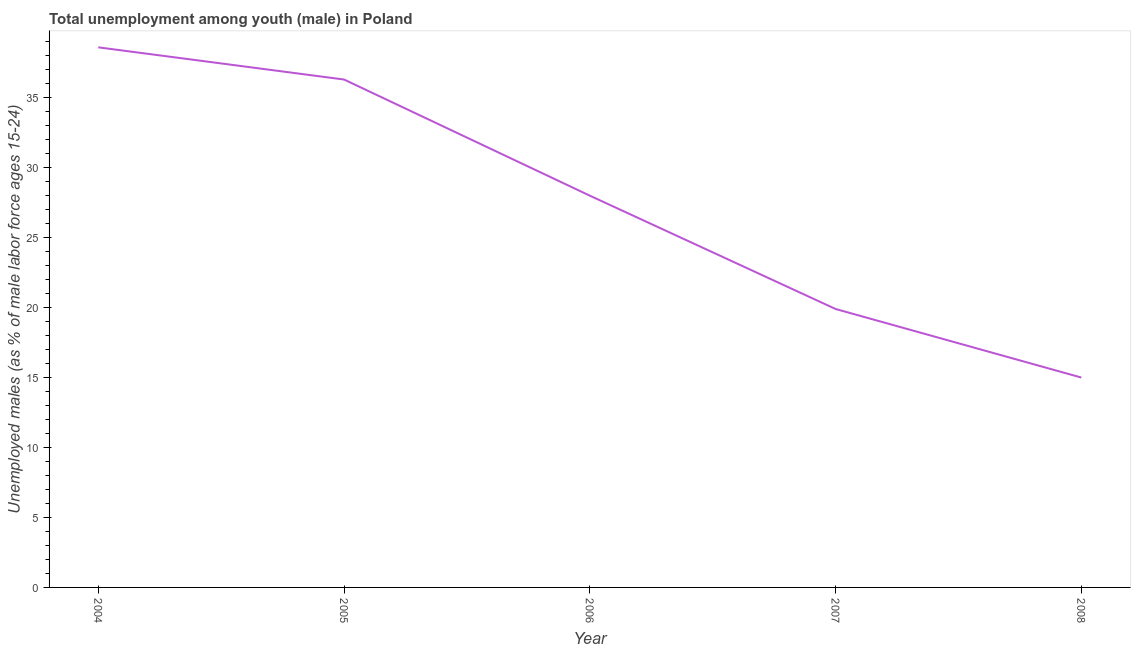What is the unemployed male youth population in 2007?
Your answer should be compact. 19.9. Across all years, what is the maximum unemployed male youth population?
Make the answer very short. 38.6. In which year was the unemployed male youth population maximum?
Keep it short and to the point. 2004. In which year was the unemployed male youth population minimum?
Offer a very short reply. 2008. What is the sum of the unemployed male youth population?
Offer a very short reply. 137.8. What is the difference between the unemployed male youth population in 2006 and 2007?
Provide a short and direct response. 8.1. What is the average unemployed male youth population per year?
Offer a terse response. 27.56. In how many years, is the unemployed male youth population greater than 16 %?
Ensure brevity in your answer.  4. What is the ratio of the unemployed male youth population in 2005 to that in 2006?
Your answer should be very brief. 1.3. Is the unemployed male youth population in 2005 less than that in 2006?
Provide a short and direct response. No. What is the difference between the highest and the second highest unemployed male youth population?
Your response must be concise. 2.3. Is the sum of the unemployed male youth population in 2004 and 2005 greater than the maximum unemployed male youth population across all years?
Your answer should be very brief. Yes. What is the difference between the highest and the lowest unemployed male youth population?
Offer a very short reply. 23.6. How many years are there in the graph?
Keep it short and to the point. 5. What is the title of the graph?
Keep it short and to the point. Total unemployment among youth (male) in Poland. What is the label or title of the Y-axis?
Provide a short and direct response. Unemployed males (as % of male labor force ages 15-24). What is the Unemployed males (as % of male labor force ages 15-24) of 2004?
Keep it short and to the point. 38.6. What is the Unemployed males (as % of male labor force ages 15-24) in 2005?
Your response must be concise. 36.3. What is the Unemployed males (as % of male labor force ages 15-24) in 2006?
Provide a succinct answer. 28. What is the Unemployed males (as % of male labor force ages 15-24) of 2007?
Make the answer very short. 19.9. What is the Unemployed males (as % of male labor force ages 15-24) in 2008?
Provide a succinct answer. 15. What is the difference between the Unemployed males (as % of male labor force ages 15-24) in 2004 and 2005?
Your answer should be compact. 2.3. What is the difference between the Unemployed males (as % of male labor force ages 15-24) in 2004 and 2008?
Make the answer very short. 23.6. What is the difference between the Unemployed males (as % of male labor force ages 15-24) in 2005 and 2007?
Offer a terse response. 16.4. What is the difference between the Unemployed males (as % of male labor force ages 15-24) in 2005 and 2008?
Provide a succinct answer. 21.3. What is the ratio of the Unemployed males (as % of male labor force ages 15-24) in 2004 to that in 2005?
Offer a very short reply. 1.06. What is the ratio of the Unemployed males (as % of male labor force ages 15-24) in 2004 to that in 2006?
Your response must be concise. 1.38. What is the ratio of the Unemployed males (as % of male labor force ages 15-24) in 2004 to that in 2007?
Keep it short and to the point. 1.94. What is the ratio of the Unemployed males (as % of male labor force ages 15-24) in 2004 to that in 2008?
Give a very brief answer. 2.57. What is the ratio of the Unemployed males (as % of male labor force ages 15-24) in 2005 to that in 2006?
Ensure brevity in your answer.  1.3. What is the ratio of the Unemployed males (as % of male labor force ages 15-24) in 2005 to that in 2007?
Your answer should be compact. 1.82. What is the ratio of the Unemployed males (as % of male labor force ages 15-24) in 2005 to that in 2008?
Provide a short and direct response. 2.42. What is the ratio of the Unemployed males (as % of male labor force ages 15-24) in 2006 to that in 2007?
Your answer should be very brief. 1.41. What is the ratio of the Unemployed males (as % of male labor force ages 15-24) in 2006 to that in 2008?
Provide a short and direct response. 1.87. What is the ratio of the Unemployed males (as % of male labor force ages 15-24) in 2007 to that in 2008?
Make the answer very short. 1.33. 